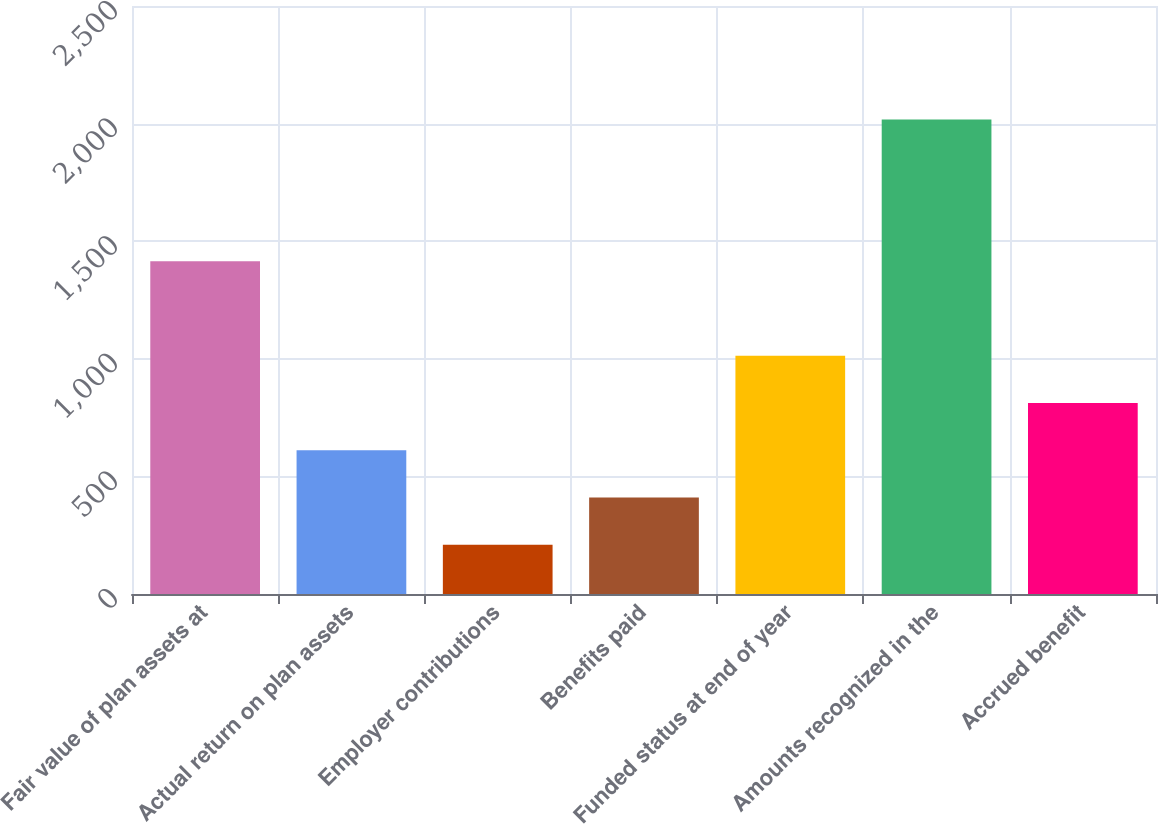Convert chart to OTSL. <chart><loc_0><loc_0><loc_500><loc_500><bar_chart><fcel>Fair value of plan assets at<fcel>Actual return on plan assets<fcel>Employer contributions<fcel>Benefits paid<fcel>Funded status at end of year<fcel>Amounts recognized in the<fcel>Accrued benefit<nl><fcel>1414.3<fcel>610.7<fcel>208.9<fcel>409.8<fcel>1012.5<fcel>2017<fcel>811.6<nl></chart> 